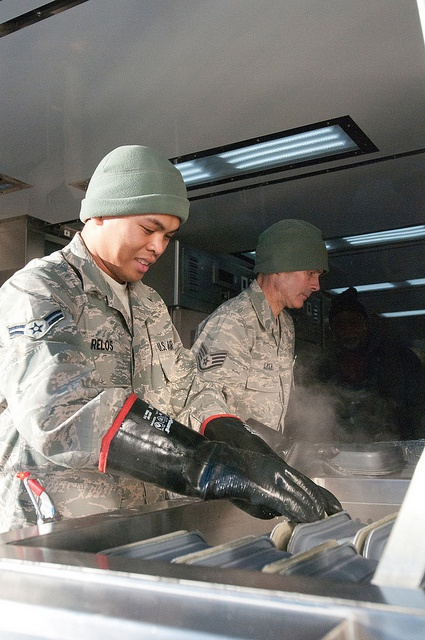Describe the objects in this image and their specific colors. I can see people in black, gray, darkgray, and white tones, sink in black, gray, and darkgray tones, and people in black, darkgray, gray, and tan tones in this image. 